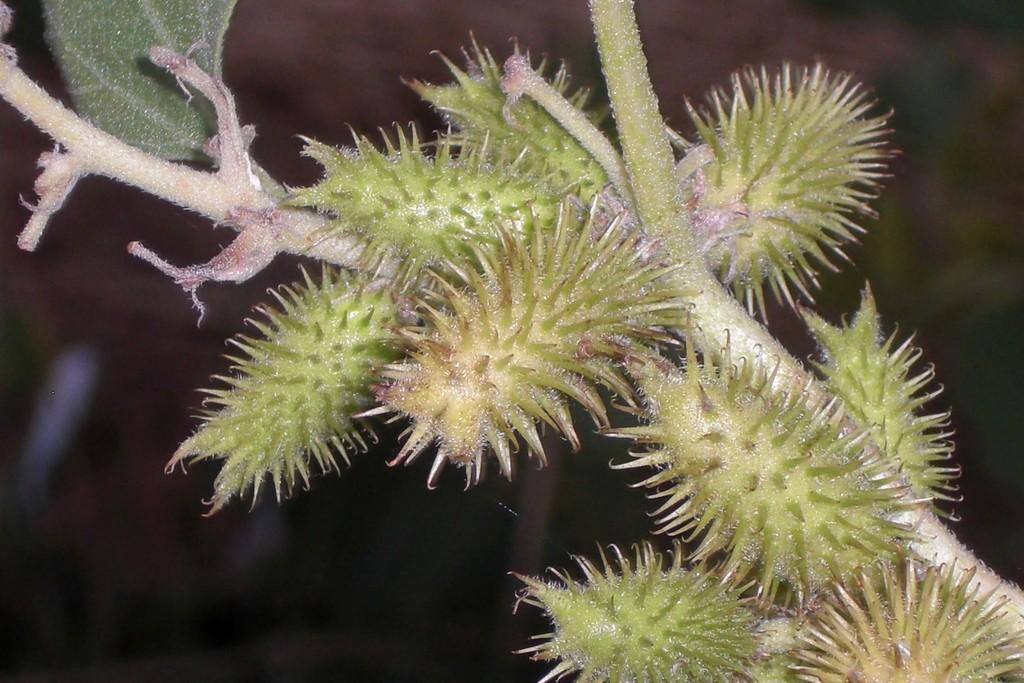What type of plant can be seen in the image? There is a thorn plant in the image. What color is the horse's skirt in the image? There is no horse or skirt present in the image; it only features a thorn plant. 